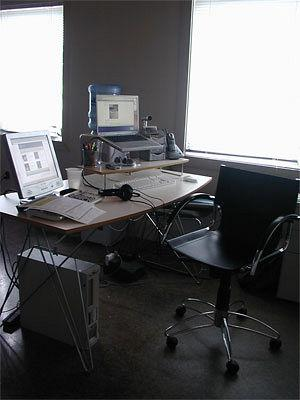This computer desk is in what type of building? Please explain your reasoning. commercial office. The windows are very large and plain and the floor is tile so it looks industrial 